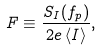<formula> <loc_0><loc_0><loc_500><loc_500>F \equiv \frac { S _ { I } ( f _ { p } ) } { 2 e \left \langle I \right \rangle } ,</formula> 